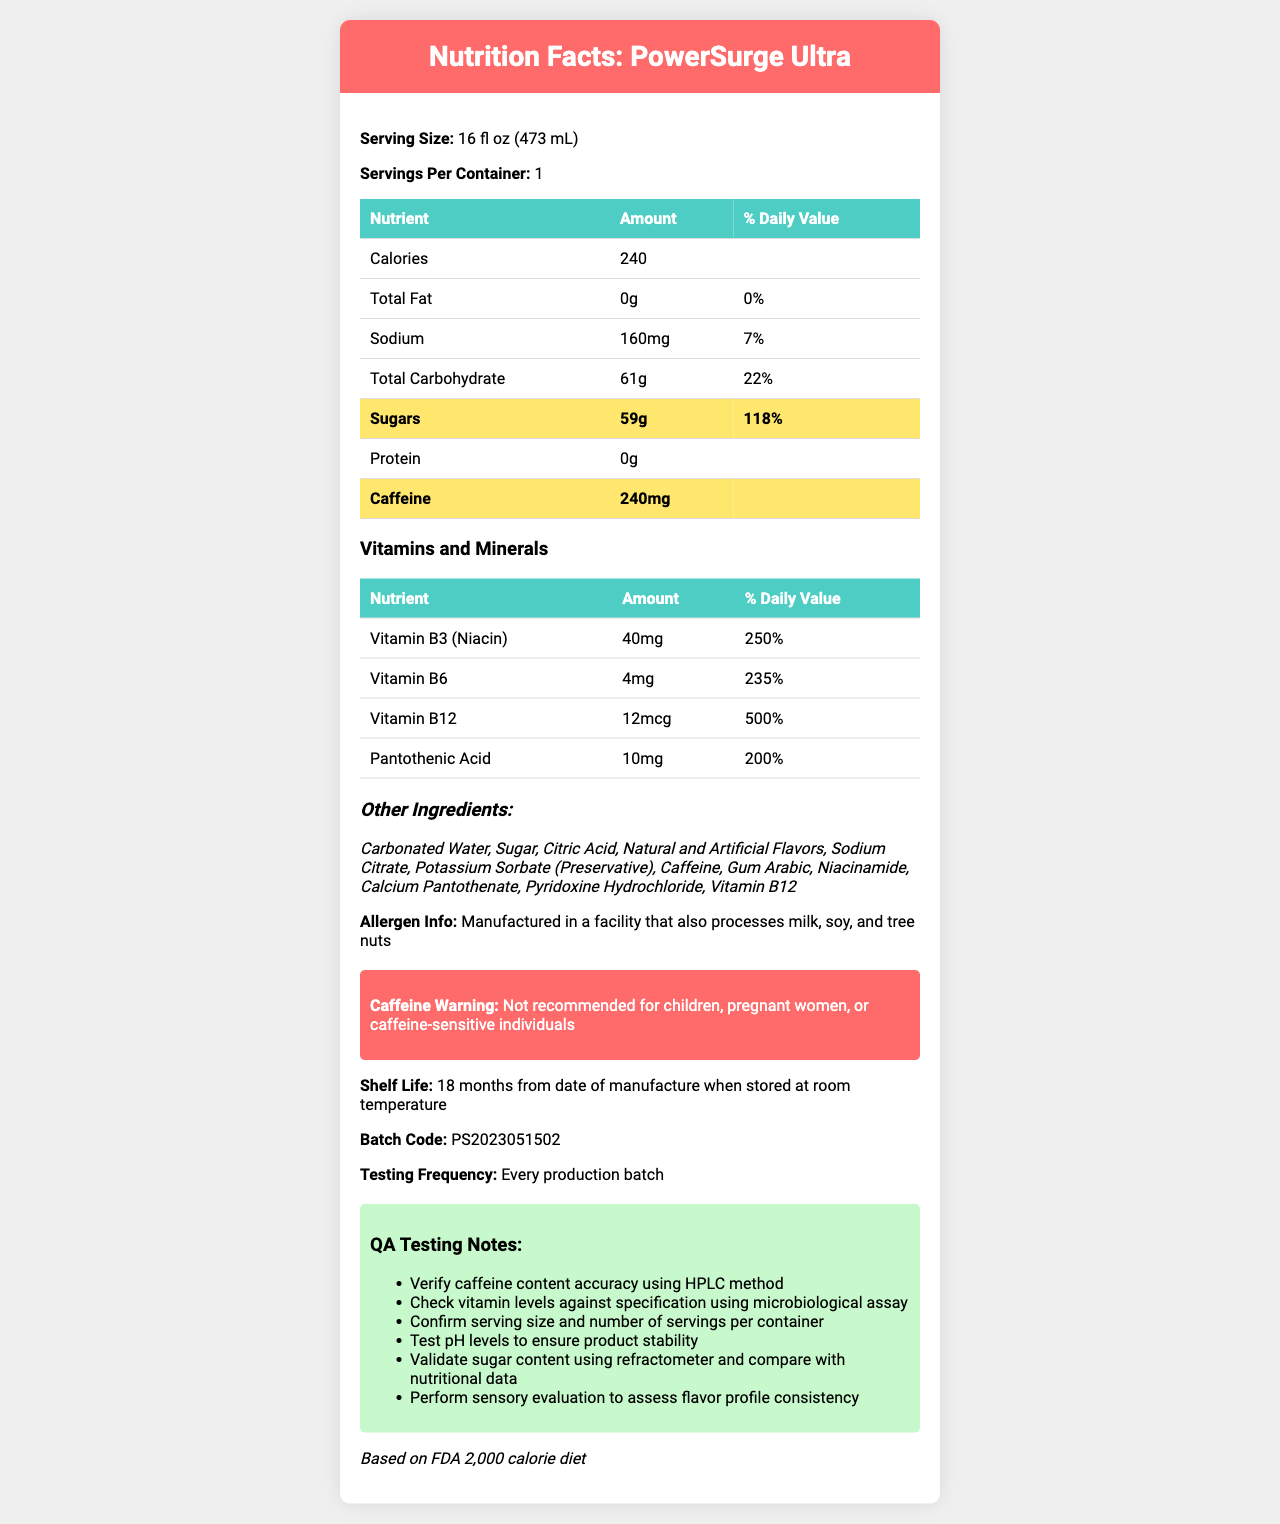what is the serving size of PowerSurge Ultra? The serving size is explicitly listed as "16 fl oz (473 mL)" in the document.
Answer: 16 fl oz (473 mL) how many calories are in one serving of PowerSurge Ultra? The calories per serving are clearly stated in the document as "240 calories."
Answer: 240 how much sodium does PowerSurge Ultra contain? The document shows that the sodium content is "160 mg."
Answer: 160 mg what is the caffeine content of PowerSurge Ultra? The nutrition facts indicate that the drink contains "240 mg" of caffeine.
Answer: 240 mg what is the daily value percentage of sugars in PowerSurge Ultra? The document lists the daily value for sugars as "118%."
Answer: 118% which vitamin has the highest daily value percentage? A. Vitamin B3 (Niacin) B. Vitamin B6 C. Vitamin B12 D. Pantothenic Acid Vitamin B12 has a daily value percentage of "500%," which is the highest among the listed vitamins and minerals.
Answer: C what is the allergen information provided for PowerSurge Ultra? The document states that the product is "Manufactured in a facility that also processes milk, soy, and tree nuts."
Answer: Manufactured in a facility that also processes milk, soy, and tree nuts based on the document, should children consume PowerSurge Ultra? The document includes a warning that the product is "Not recommended for children."
Answer: No how long is the shelf life of PowerSurge Ultra? The document mentions that the shelf life is "18 months from date of manufacture when stored at room temperature."
Answer: 18 months is the protein content of PowerSurge Ultra high or low? The document lists the protein content as "0g," indicating it is very low.
Answer: Low what are the main ingredients in PowerSurge Ultra? The document enumerates these ingredients under the section "Other Ingredients."
Answer: Carbonated Water, Sugar, Citric Acid, Natural and Artificial Flavors, Sodium Citrate, Potassium Sorbate (Preservative), Caffeine, Gum Arabic, Niacinamide, Calcium Pantothenate, Pyridoxine Hydrochloride, Vitamin B12 how frequently is PowerSurge Ultra tested? A. Every week B. Every production batch C. Monthly D. Annually The document states that testing is done "Every production batch."
Answer: B which vitamin is present in the amount of 4mg per serving? According to the section on vitamins and minerals, "Vitamin B6" is listed as having 4mg per serving.
Answer: Vitamin B6 is the sugar content verified against nutritional data during QA testing? One of the QA testing notes specifies "Validate sugar content using refractometer and compare with nutritional data."
Answer: Yes summarize the key information in the PowerSurge Ultra Nutrition Facts Label. This summary encapsulates the main elements of the nutrition facts, ingredient details, and additional important information presented in the document.
Answer: The nutrition facts label for PowerSurge Ultra includes details about serving size (16 fl oz), calories (240), and various nutrients such as total fat (0g), sodium (160mg), total carbohydrates (61g), and sugars (59g). The label also lists a high caffeine content (240mg) and added vitamins with significant daily values, including Vitamin B3, Vitamin B6, Vitamin B12, and Pantothenic Acid. Other ingredients and allergen information are provided, along with QA testing notes, regulatory compliance warnings, and shelf life. how much sodium chloride is added to PowerSurge Ultra? The document does not specify the amount of sodium chloride, only listing the sodium content.
Answer: Cannot be determined 